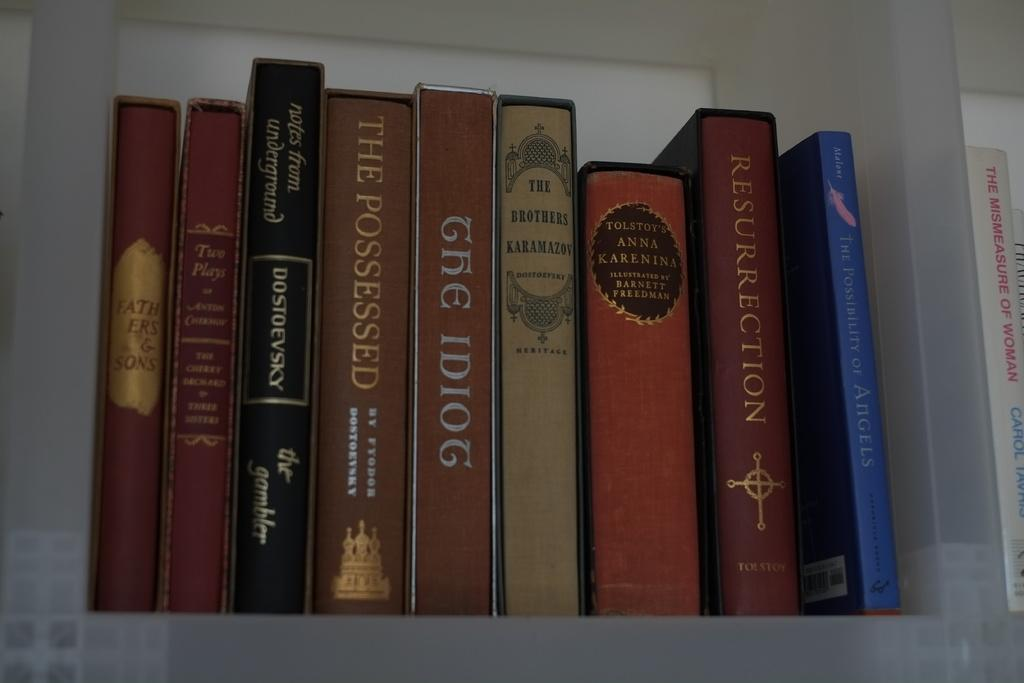What objects are present in the image? There are books in the image. Where are the books located? The books are in a rack. Can you describe the appearance of the books? The books are colorful. What can be found on the surface of each book? There is writing on each book. What type of cracker is being used to hold the books together in the image? There is no cracker present in the image; the books are in a rack. What historical event is depicted on the books in the image? The provided facts do not mention any historical events or themes related to the books in the image. 